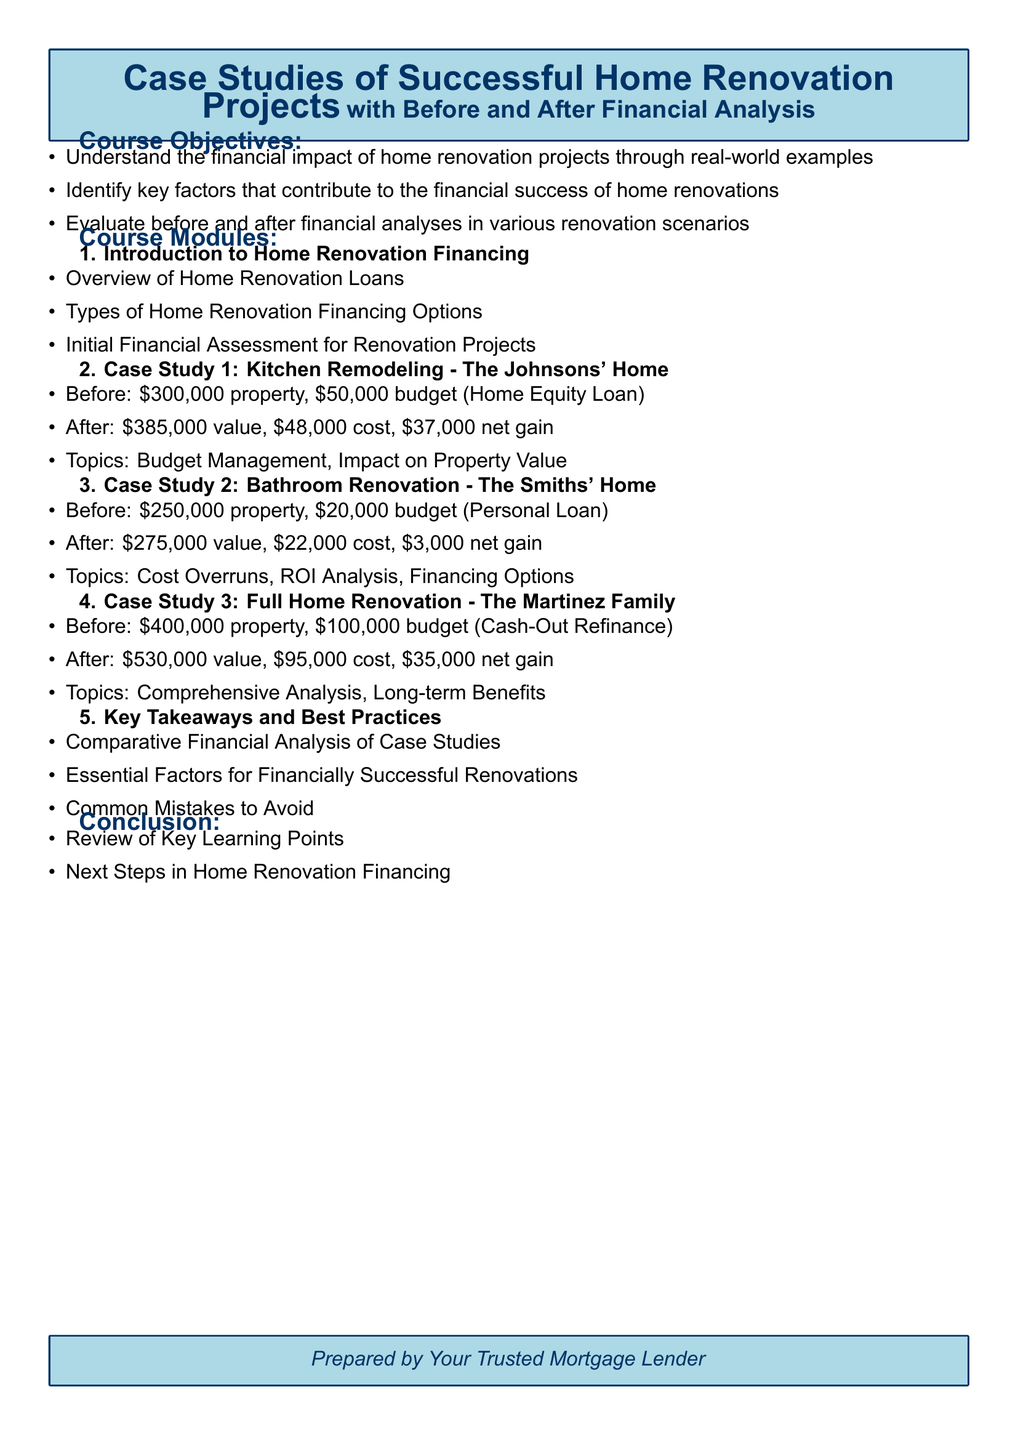What is the main focus of the course? The course focuses on understanding the financial impact of home renovation projects through real-world examples.
Answer: Financial impact of home renovation projects What was the budget for the Johnsons' kitchen remodeling? The Johnsons' kitchen remodeling budget was \$50,000.
Answer: \$50,000 What was the property value after the Smiths' bathroom renovation? After the renovation, the Smiths' property value was \$275,000.
Answer: \$275,000 What financing option did the Martinez family use for their renovation? The Martinez family used Cash-Out Refinance for their renovation financing.
Answer: Cash-Out Refinance What is a key takeaway from the course? A key takeaway is the identification of essential factors for financially successful renovations.
Answer: Essential factors for financially successful renovations What was the net gain for the Johnsons' renovation project? The net gain for the Johnsons' renovation project was \$37,000.
Answer: \$37,000 How much did the Smiths spend on their renovation? The Smiths spent \$22,000 on their bathroom renovation.
Answer: \$22,000 What type of loan did the Smiths use for renovation? The Smiths used a Personal Loan for their renovation financing.
Answer: Personal Loan 